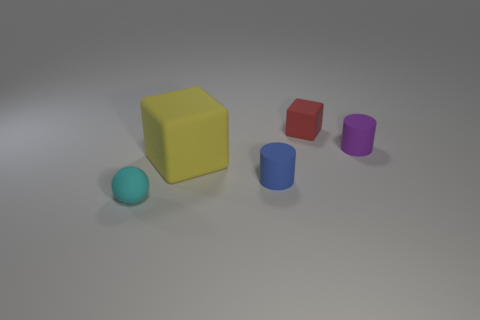Are there any other things that are the same size as the yellow matte thing?
Make the answer very short. No. What shape is the blue object that is the same size as the red rubber object?
Your answer should be compact. Cylinder. What number of other objects are the same shape as the cyan rubber thing?
Give a very brief answer. 0. Is the size of the blue rubber object the same as the thing that is in front of the blue rubber cylinder?
Make the answer very short. Yes. What number of things are either small matte cylinders in front of the small purple thing or small brown cylinders?
Your response must be concise. 1. There is a small matte object behind the purple matte cylinder; what is its shape?
Offer a very short reply. Cube. Are there the same number of red blocks on the right side of the red matte object and small cyan matte spheres that are behind the small purple thing?
Your answer should be compact. Yes. There is a small matte thing that is both behind the small cyan rubber object and in front of the small purple thing; what is its color?
Make the answer very short. Blue. Is the blue rubber object the same size as the red block?
Your answer should be very brief. Yes. What number of large objects are matte cylinders or yellow rubber things?
Your response must be concise. 1. 